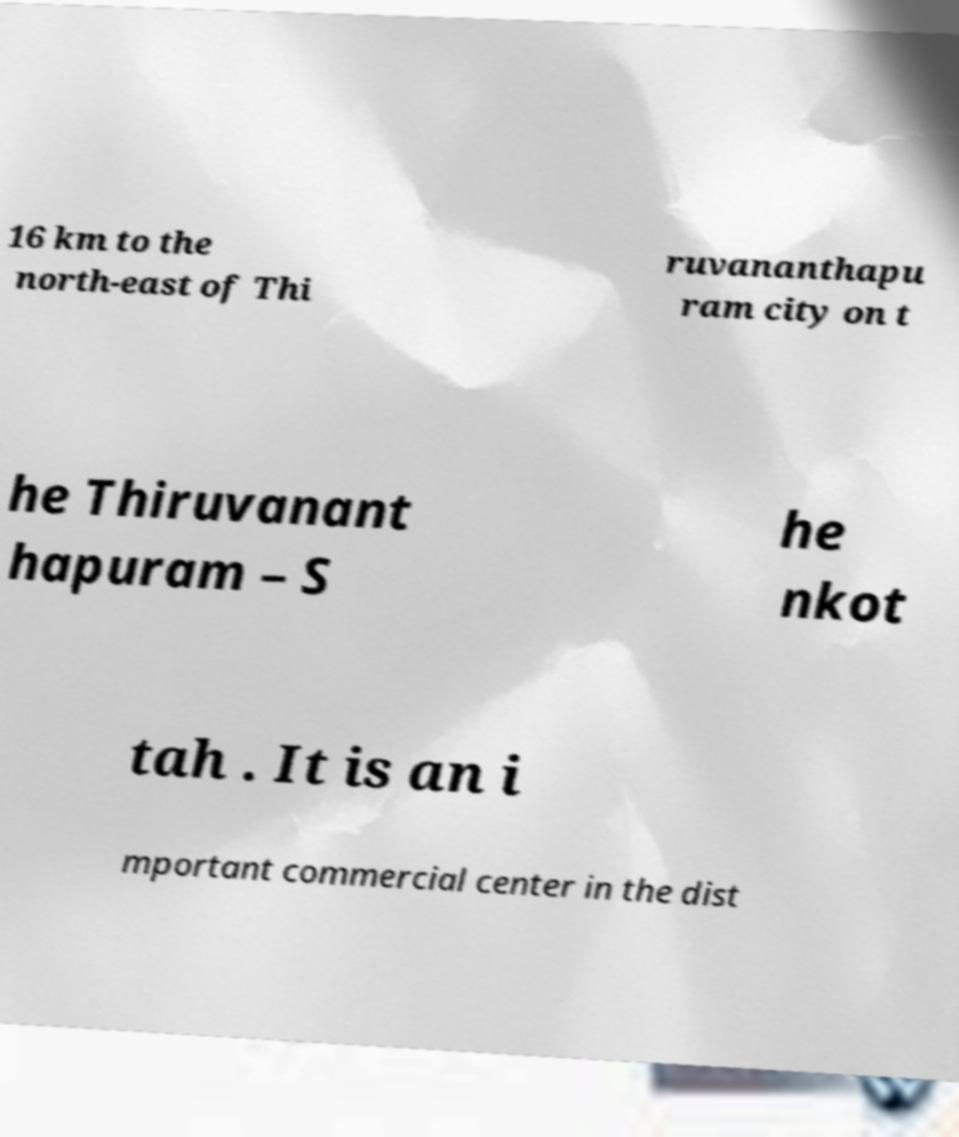There's text embedded in this image that I need extracted. Can you transcribe it verbatim? 16 km to the north-east of Thi ruvananthapu ram city on t he Thiruvanant hapuram – S he nkot tah . It is an i mportant commercial center in the dist 